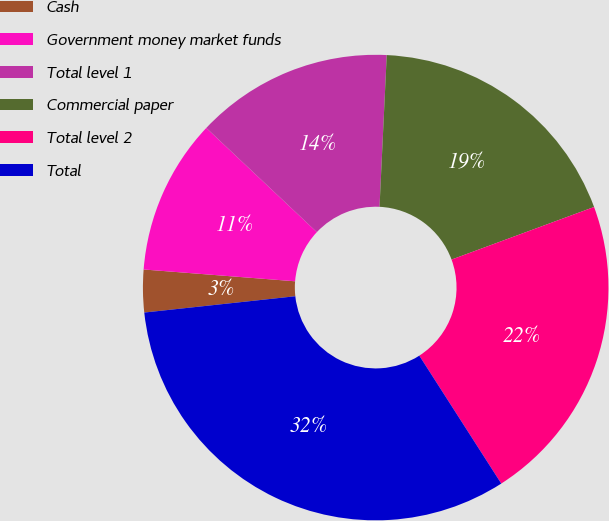Convert chart to OTSL. <chart><loc_0><loc_0><loc_500><loc_500><pie_chart><fcel>Cash<fcel>Government money market funds<fcel>Total level 1<fcel>Commercial paper<fcel>Total level 2<fcel>Total<nl><fcel>2.95%<fcel>10.79%<fcel>13.73%<fcel>18.62%<fcel>21.56%<fcel>32.36%<nl></chart> 